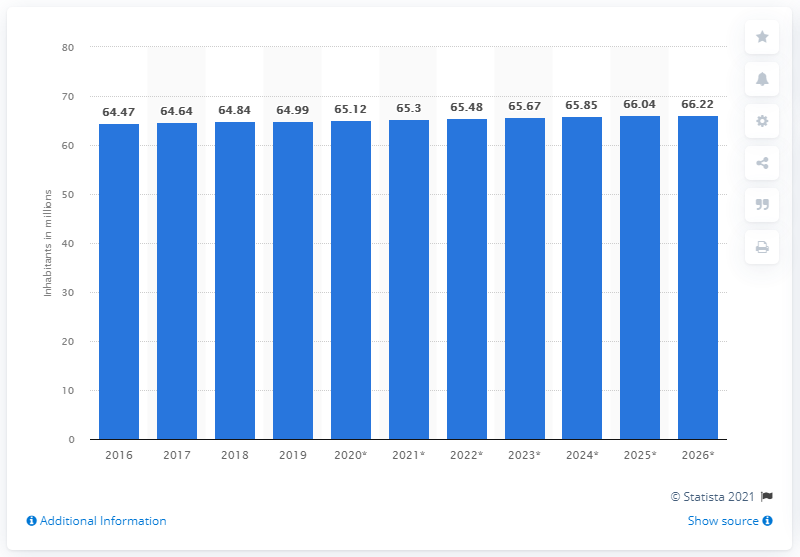Outline some significant characteristics in this image. According to available data, the population of France in 2019 was approximately 65.48 million. 